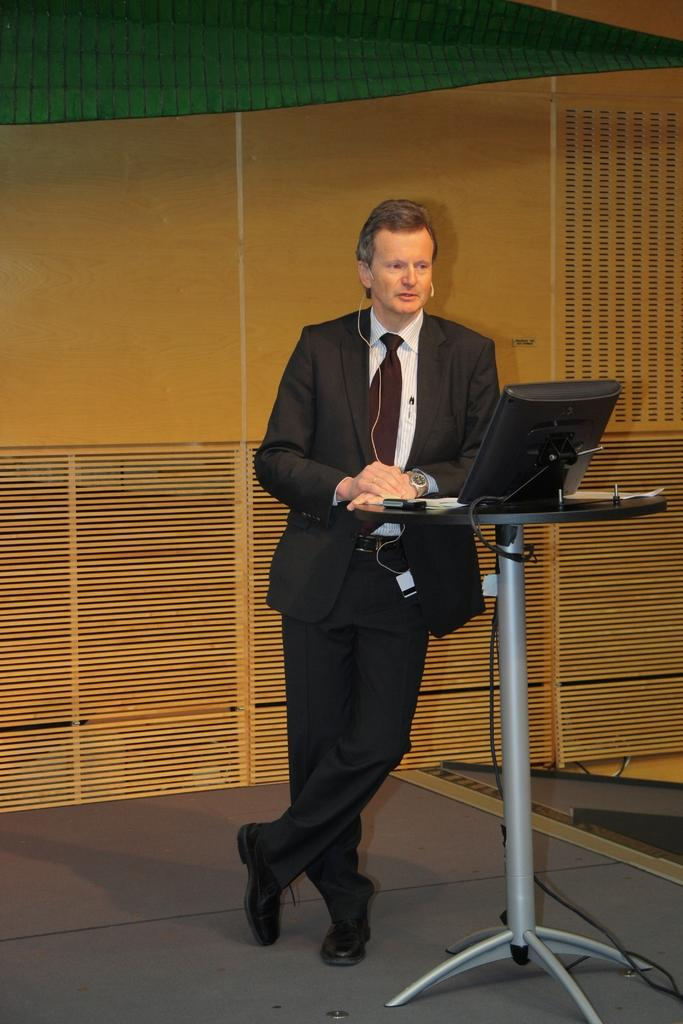What is the person in the image doing? The person is standing in the image. What can be seen on the person? The person is wearing a mic and a watch. What is in front of the person? There is a table in front of the person. What is on the table? There is a screen on the table. What is visible in the background? There is a wall in the background. What type of airplane is the writer using as an apparatus in the image? There is no airplane or writer present in the image, and no apparatus is being used. 